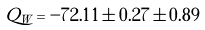<formula> <loc_0><loc_0><loc_500><loc_500>Q _ { W } = - 7 2 . 1 1 \pm 0 . 2 7 \pm 0 . 8 9</formula> 